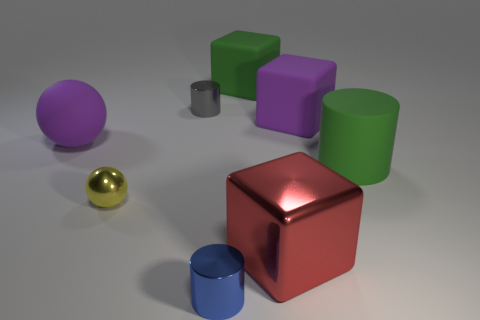Is the number of red blocks that are behind the big red metal block the same as the number of green rubber things? No, the numbers are not the same. Behind the big red metal cube, there are no red blocks visible; they are all positioned around the cube. In contrast, there are two green cylindrical rubber objects in the image. 